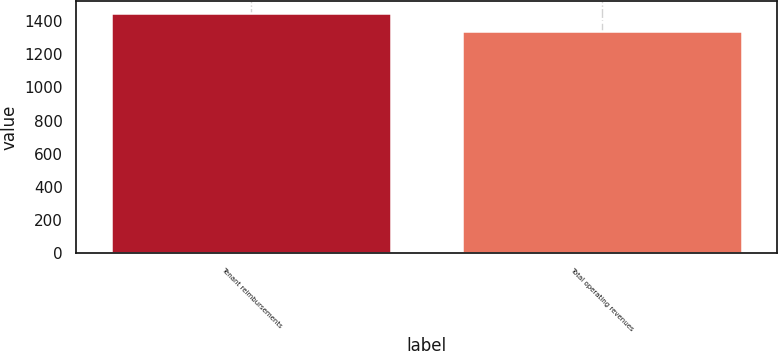Convert chart. <chart><loc_0><loc_0><loc_500><loc_500><bar_chart><fcel>Tenant reimbursements<fcel>Total operating revenues<nl><fcel>1447<fcel>1339<nl></chart> 